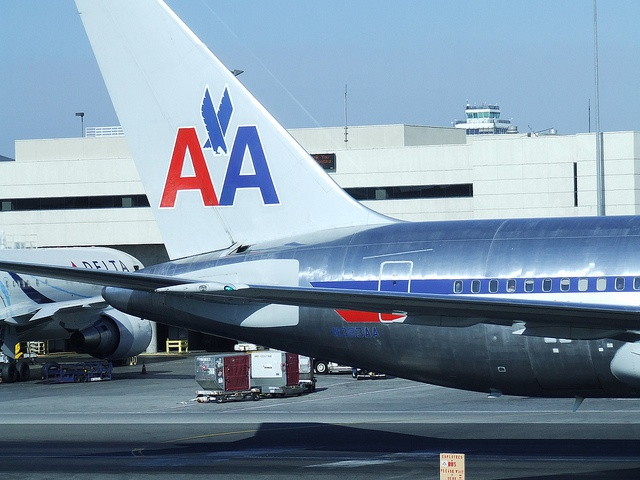Describe the objects in this image and their specific colors. I can see airplane in lightblue, black, gray, and darkblue tones and airplane in lightblue, black, and navy tones in this image. 